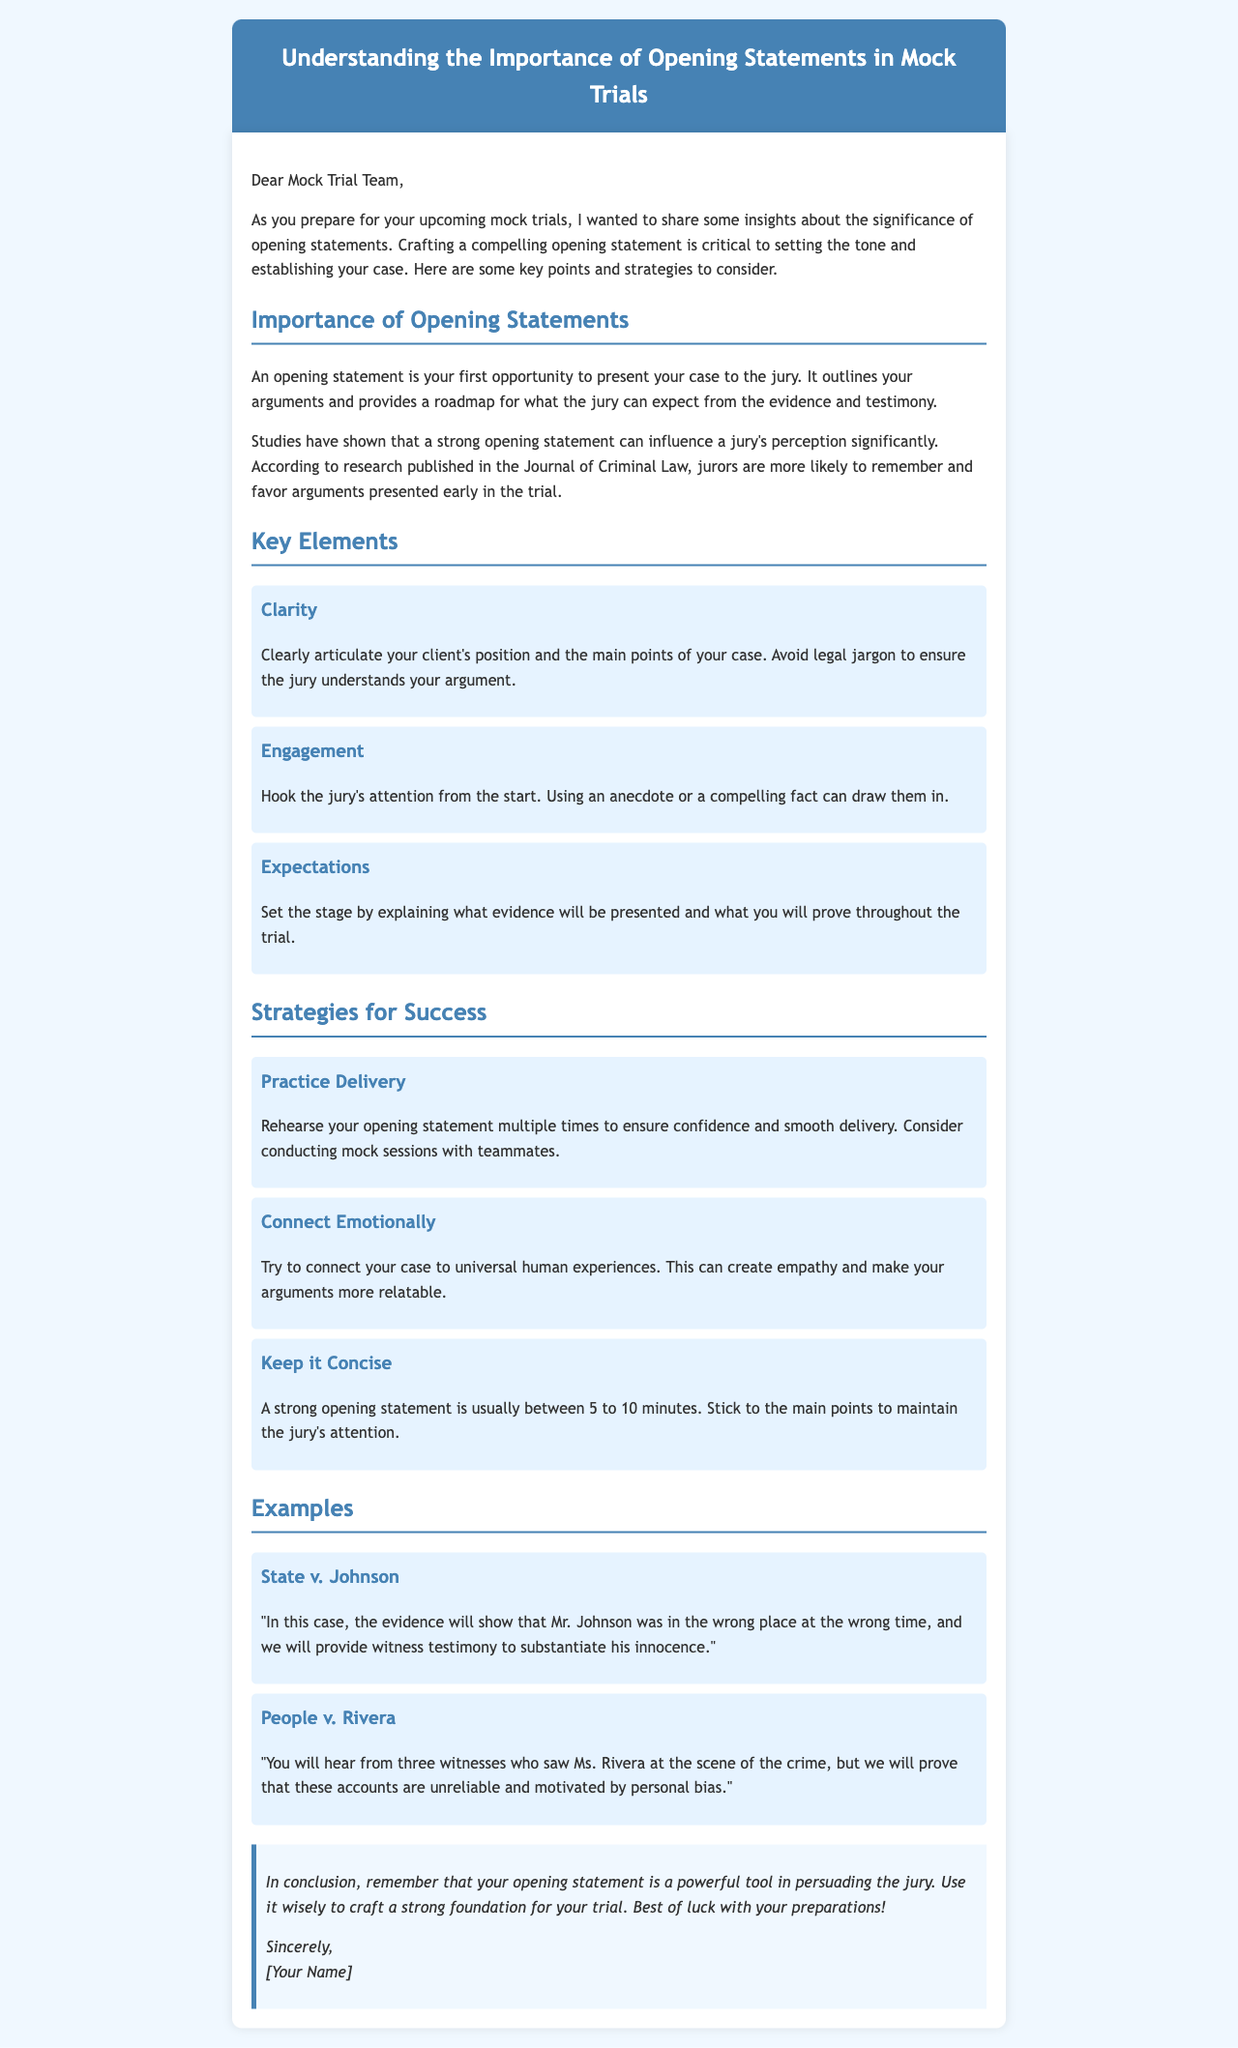what is the title of the document? The title of the document is presented in the header section, summarizing the email's focus.
Answer: Understanding the Importance of Opening Statements in Mock Trials who is the intended recipient of the email? The email is addressed to the Mock Trial Team, indicating the audience for the message.
Answer: Mock Trial Team how long should a strong opening statement be? The document specifies a time range for a strong opening statement, providing a guideline for delivery.
Answer: 5 to 10 minutes what is one key element of an opening statement? The document lists several key elements; one example can represent the main points.
Answer: Clarity name one strategy for success mentioned in the document. The document outlines various strategies, and any of them can be named.
Answer: Practice Delivery what will the evidence in the case of State v. Johnson suggest? The example indicates the focus of the evidence that will be presented in this case.
Answer: Mr. Johnson was in the wrong place at the wrong time what is a suggestion for engaging the jury's attention? The document mentions specific ways to hook the jury, emphasizing interaction in opening statements.
Answer: Using an anecdote or a compelling fact who is the author of the email? The conclusion of the email shows who is signing off the message.
Answer: [Your Name] what does the email conclude about the opening statement? The conclusion summarizes the email's main message regarding the opening statement's role.
Answer: A powerful tool in persuading the jury 